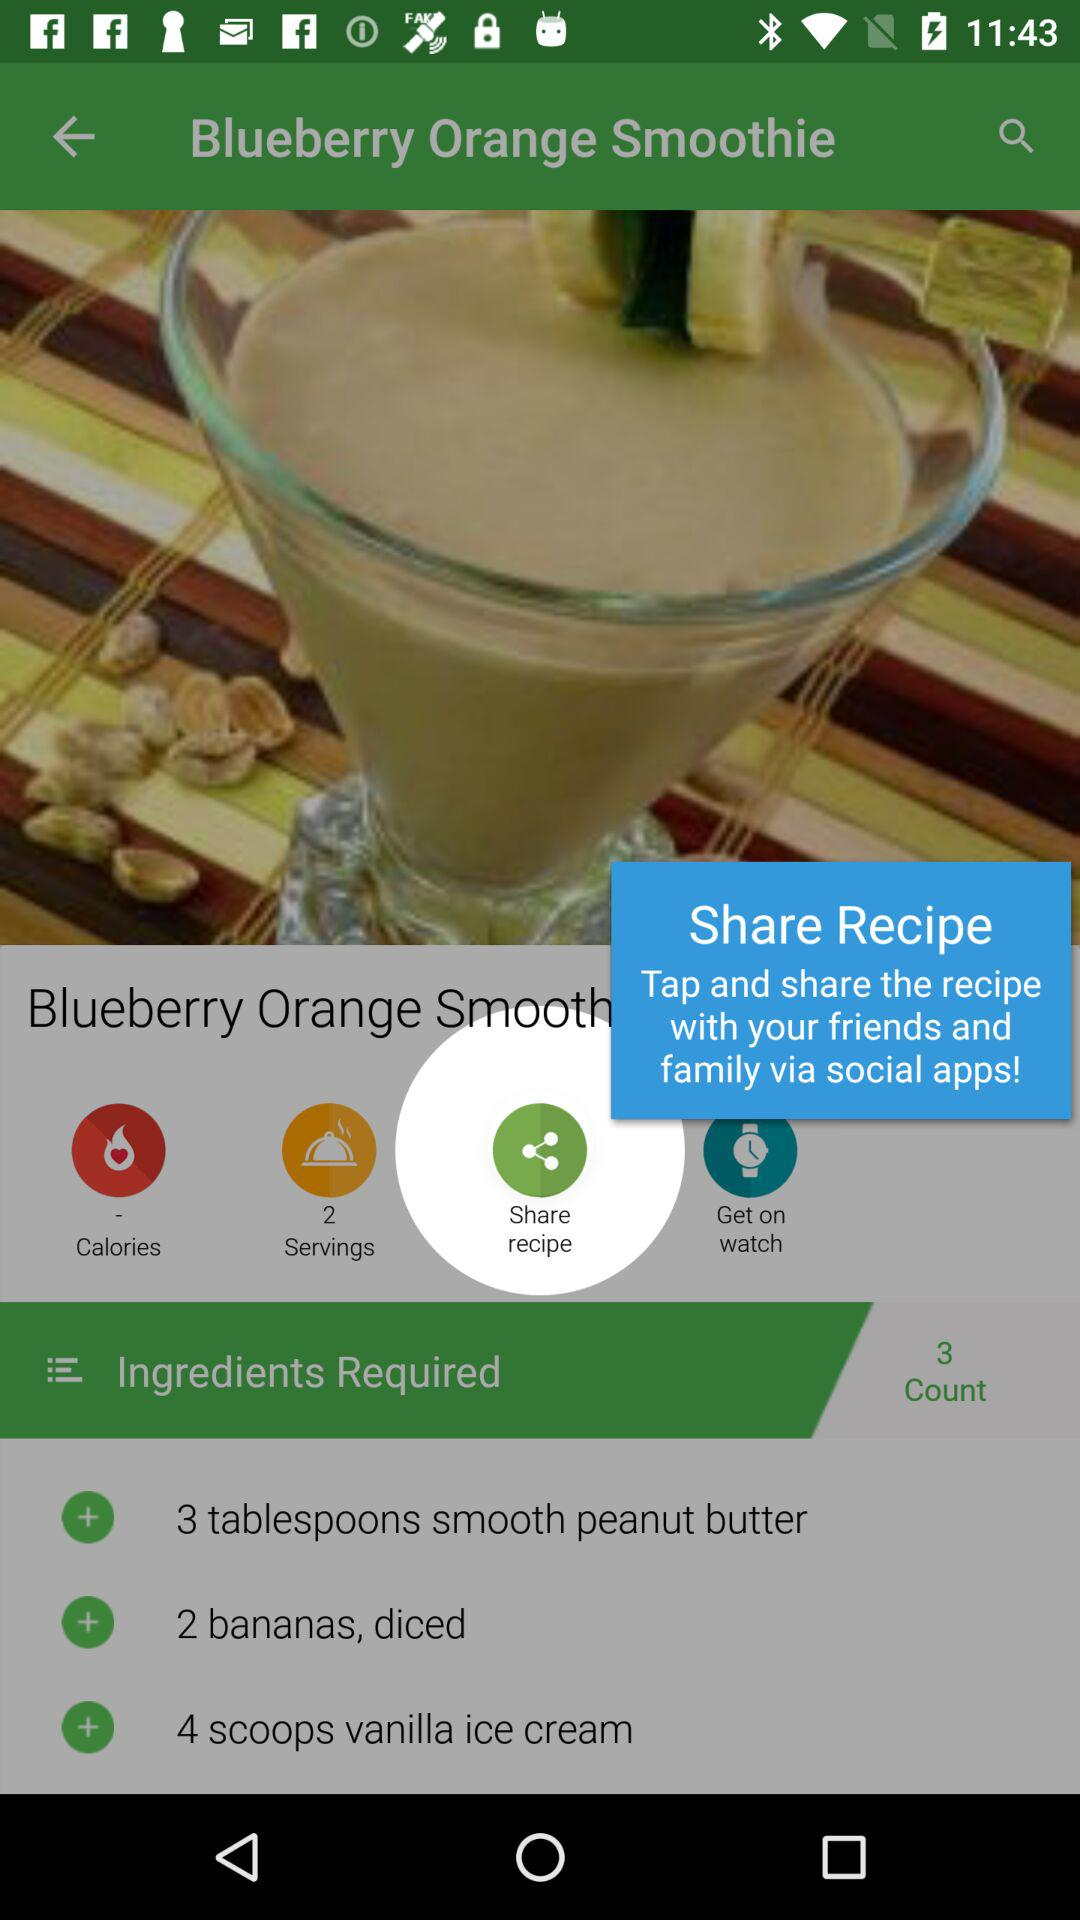How many scoops of ice-cream required? There are four scoops of ice-cream required. 